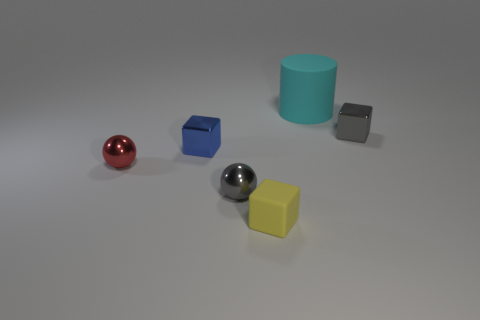Are there any yellow objects made of the same material as the cyan object?
Offer a terse response. Yes. What is the tiny gray ball that is in front of the tiny cube that is to the right of the cyan object made of?
Keep it short and to the point. Metal. What size is the object on the right side of the matte object behind the tiny gray metallic thing that is right of the big cyan cylinder?
Your answer should be compact. Small. What number of other things are the same shape as the tiny red object?
Give a very brief answer. 1. Is the color of the tiny shiny block on the right side of the tiny blue shiny cube the same as the ball right of the blue object?
Make the answer very short. Yes. What color is the ball that is the same size as the red object?
Your answer should be compact. Gray. Is the size of the metal cube to the left of the cyan thing the same as the cyan cylinder?
Make the answer very short. No. Are there the same number of red objects that are behind the cyan rubber cylinder and blocks?
Your answer should be compact. No. What number of things are either tiny blocks that are in front of the small gray metal sphere or tiny cyan matte balls?
Your answer should be very brief. 1. What is the shape of the thing that is both behind the tiny blue cube and in front of the big rubber thing?
Your answer should be compact. Cube. 